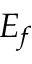Convert formula to latex. <formula><loc_0><loc_0><loc_500><loc_500>E _ { f }</formula> 